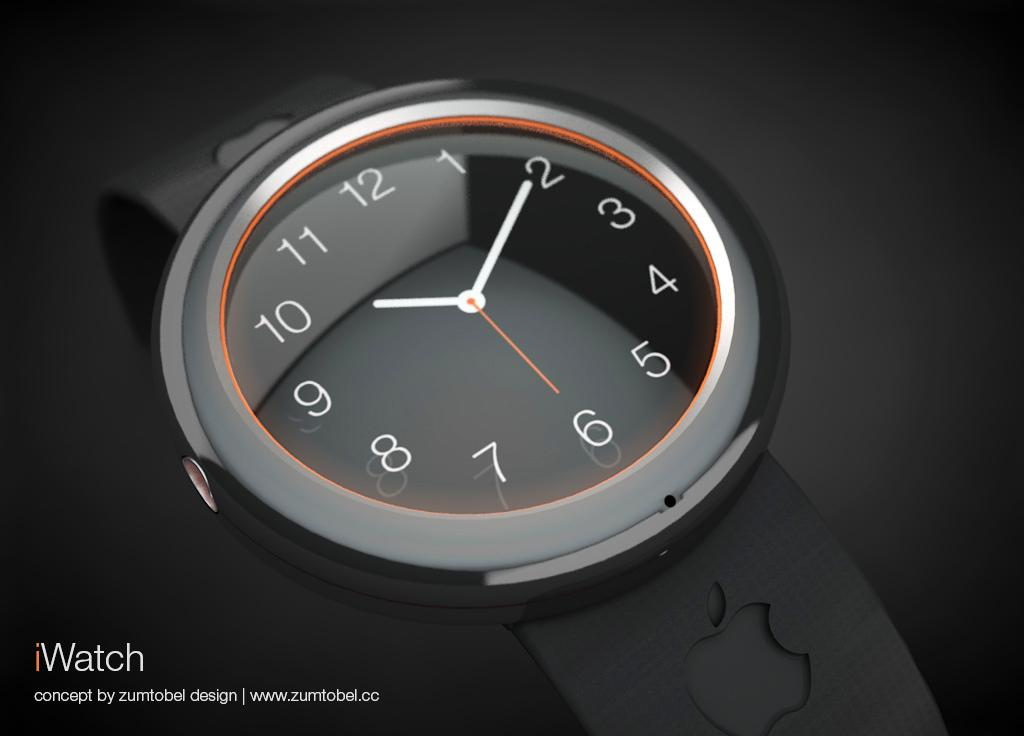<image>
Provide a brief description of the given image. A sample of an iWatch sold on zumtobel. 